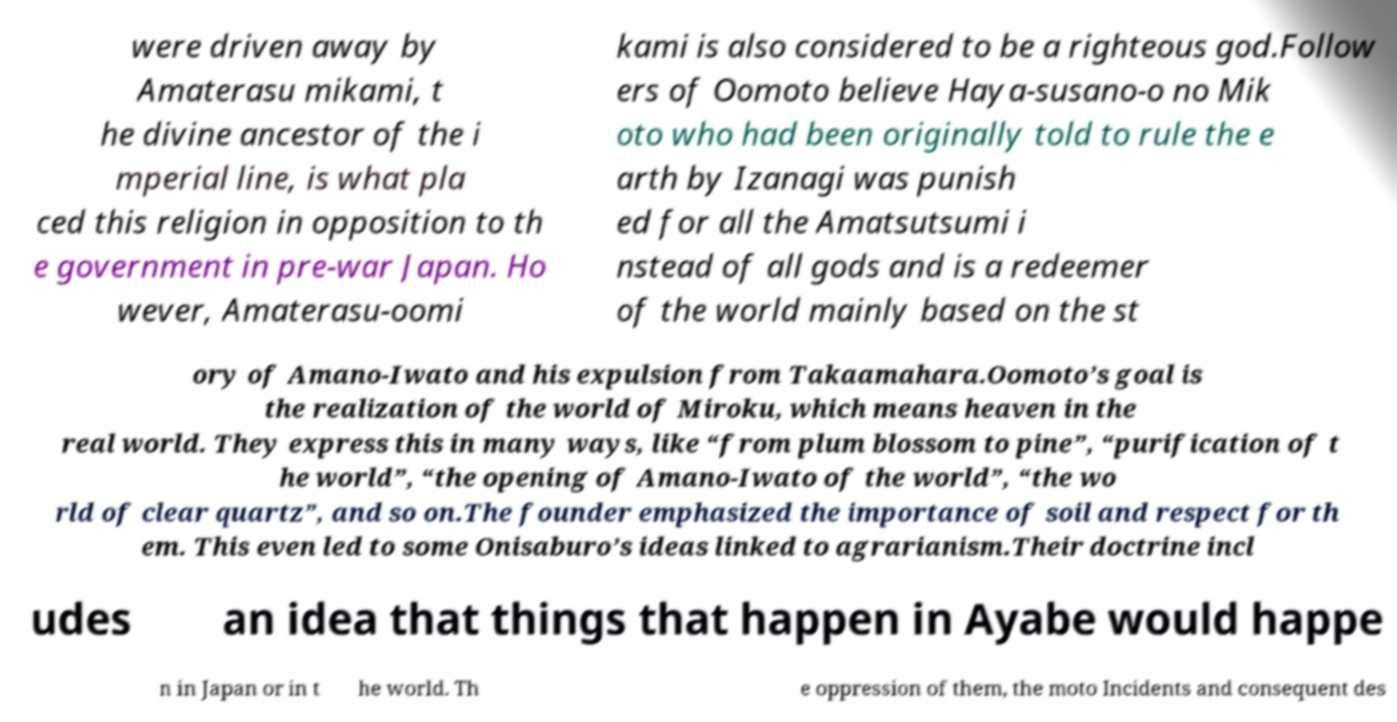Can you accurately transcribe the text from the provided image for me? were driven away by Amaterasu mikami, t he divine ancestor of the i mperial line, is what pla ced this religion in opposition to th e government in pre-war Japan. Ho wever, Amaterasu-oomi kami is also considered to be a righteous god.Follow ers of Oomoto believe Haya-susano-o no Mik oto who had been originally told to rule the e arth by Izanagi was punish ed for all the Amatsutsumi i nstead of all gods and is a redeemer of the world mainly based on the st ory of Amano-Iwato and his expulsion from Takaamahara.Oomoto’s goal is the realization of the world of Miroku, which means heaven in the real world. They express this in many ways, like “from plum blossom to pine”, “purification of t he world”, “the opening of Amano-Iwato of the world”, “the wo rld of clear quartz”, and so on.The founder emphasized the importance of soil and respect for th em. This even led to some Onisaburo’s ideas linked to agrarianism.Their doctrine incl udes an idea that things that happen in Ayabe would happe n in Japan or in t he world. Th e oppression of them, the moto Incidents and consequent des 